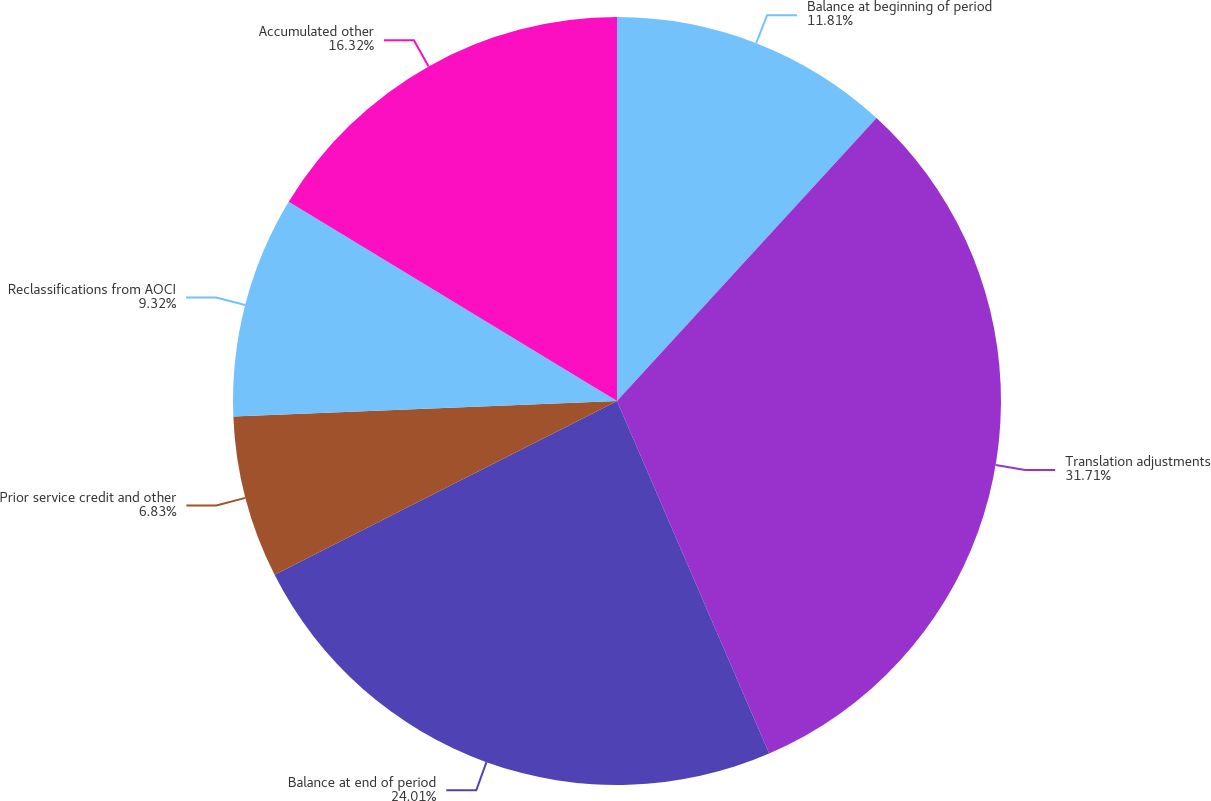Convert chart. <chart><loc_0><loc_0><loc_500><loc_500><pie_chart><fcel>Balance at beginning of period<fcel>Translation adjustments<fcel>Balance at end of period<fcel>Prior service credit and other<fcel>Reclassifications from AOCI<fcel>Accumulated other<nl><fcel>11.81%<fcel>31.7%<fcel>24.01%<fcel>6.83%<fcel>9.32%<fcel>16.32%<nl></chart> 